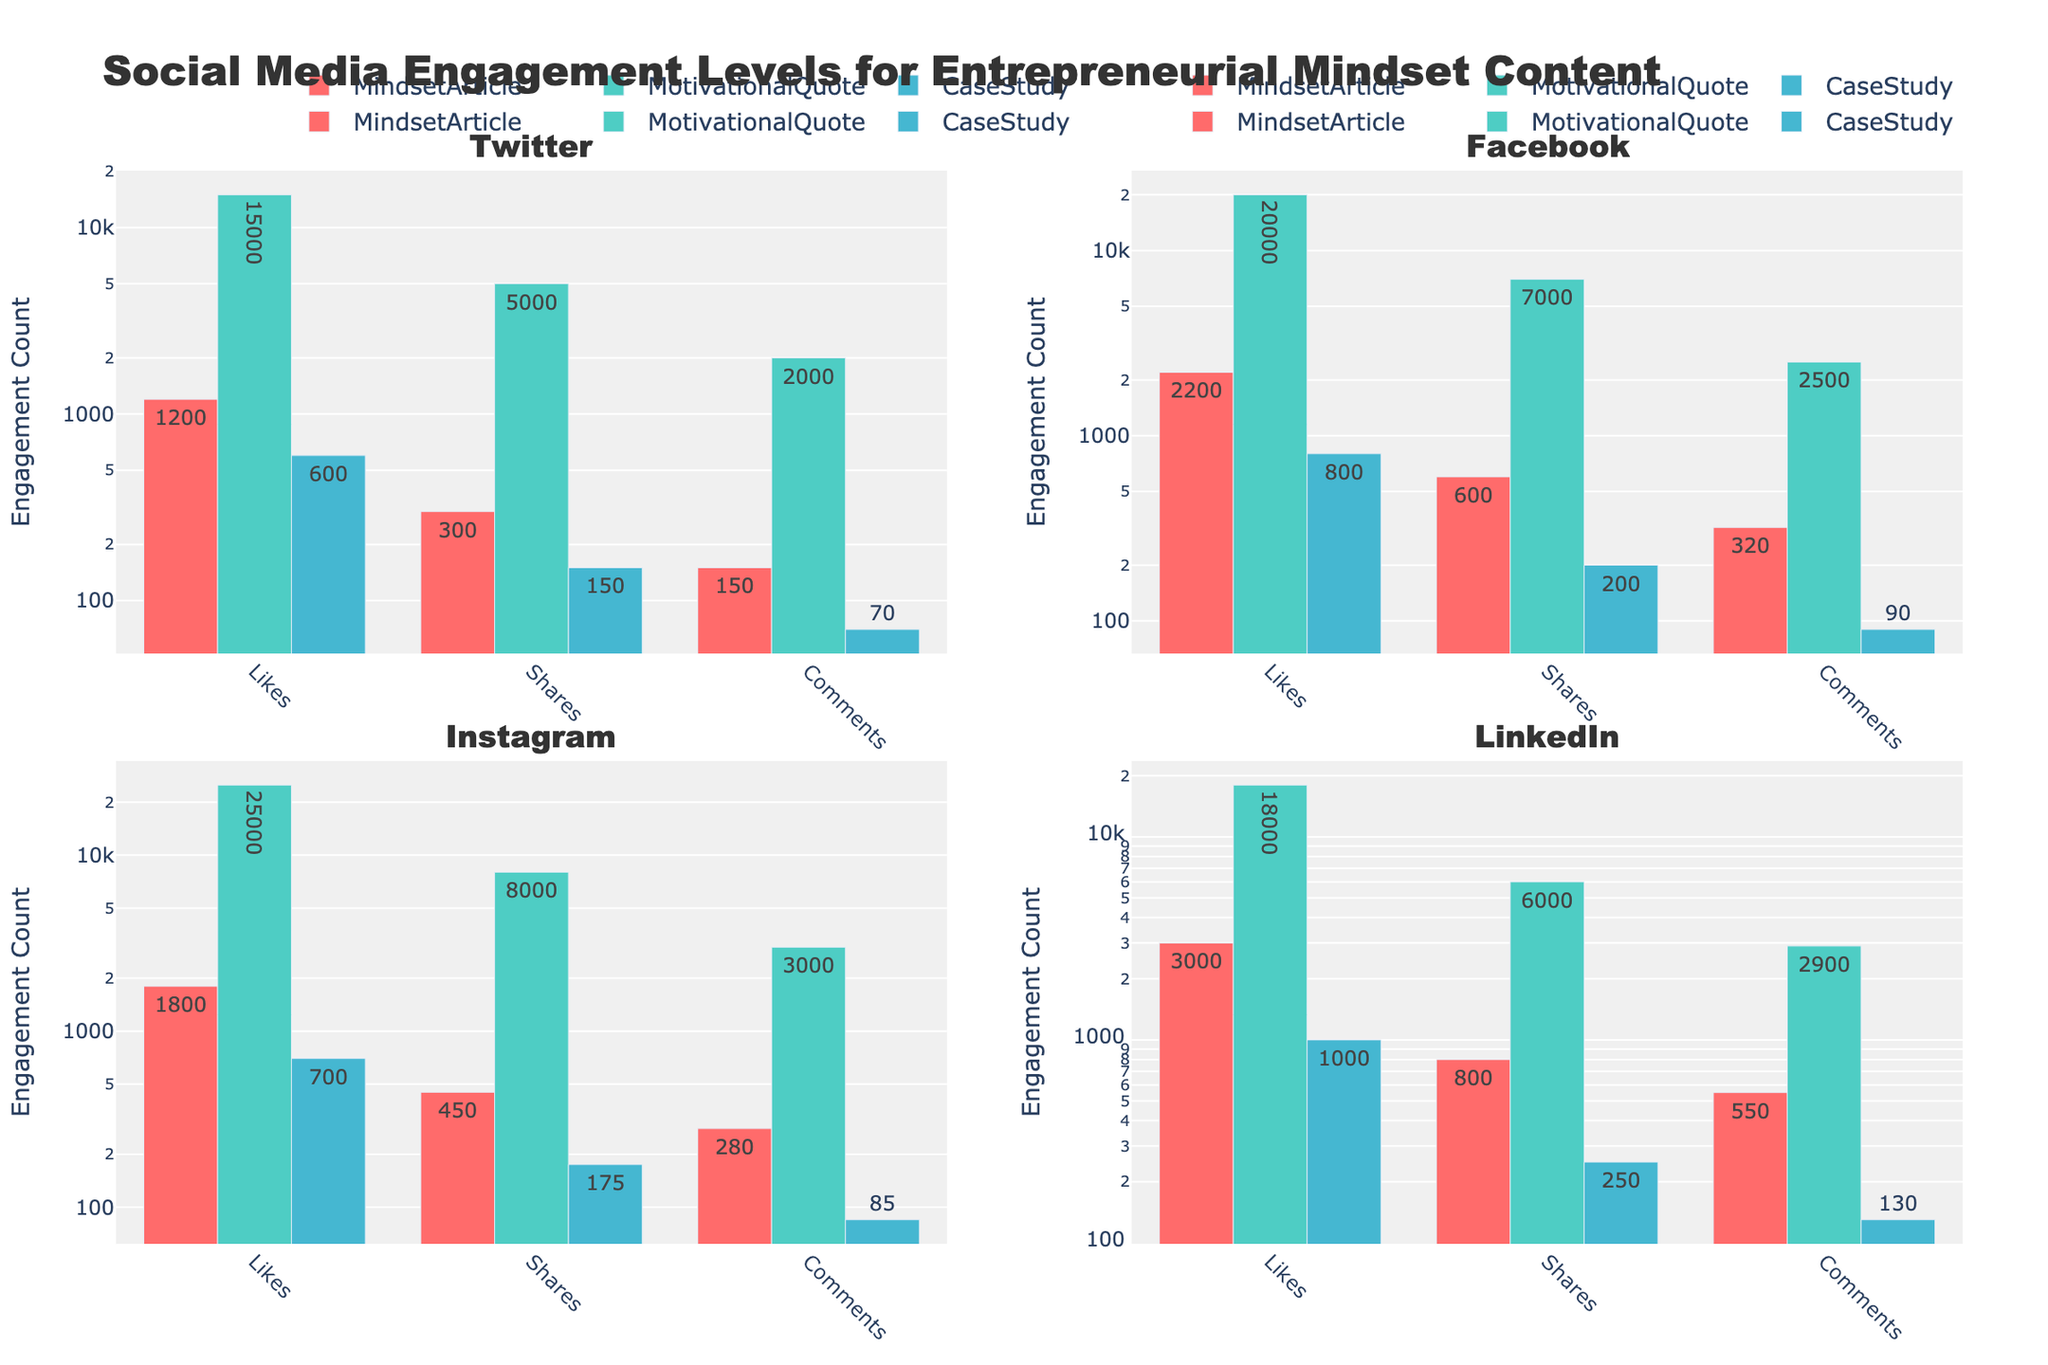What is the title of the plot? Look at the top of the figure where the main title is located. It indicates the overall theme or topic of the plot.
Answer: Social Media Engagement Levels for Entrepreneurial Mindset Content Which platform shows the highest number of likes for Mindset Articles? Compare the bars labeled "Likes" for Mindset Articles across all platforms. The highest bar represents the platform with the most likes.
Answer: LinkedIn How many likes are there for Motivational Quotes on Instagram? Find the bar that represents "Likes" for Motivational Quotes under the Instagram subplot. Read the value shown on the bar or the hovertext.
Answer: 25000 Which type of engagement has the lowest value for Case Studies on Twitter? Look at the subplot for Twitter, find the bars corresponding to Case Studies, and identify the shortest bar which represents the lowest value type of engagement.
Answer: Comments On Facebook, what is the difference in the number of shares between Motivational Quotes and Case Studies? Find the bars representing "Shares" for both Motivational Quotes and Case Studies on Facebook. Subtract the value for Case Studies from the value for Motivational Quotes.
Answer: 6800 Between Facebook and Twitter, which platform has higher comments for Mindset Articles? Compare the bars labeled "Comments" for Mindset Articles in both the Facebook and Twitter subplots. Identify the platform with the taller bar.
Answer: Facebook What is the average number of likes for Motivational Quotes across all platforms? Calculate the sum of likes for Motivational Quotes across all platforms (15000 + 20000 + 25000 + 18000) and divide by the number of platforms (4).
Answer: 19500 Compare the shares for Case Studies on LinkedIn and Instagram. Which one is greater and by how much? Look at the subplot for LinkedIn and Instagram, find the bars representing "Shares" for Case Studies on each platform, and compare their heights. Subtract the smaller value from the larger value to find the difference.
Answer: LinkedIn by 75 What is the general trend in the number of likes for Motivational Quotes compared to other content types across platforms? Observe the height of bars representing "Likes" for Motivational Quotes in all subplots and compare them with the bars for other content types like Mindset Articles and Case Studies.
Answer: Motivational Quotes generally receive higher likes across all platforms How do the engagement levels for Mindset Articles compare between Instagram and Facebook? Compare the heights of the bars representing "Likes," "Shares," and "Comments" for Mindset Articles between the subplots for Instagram and Facebook. Identify which platform has taller bars and for which types of engagement.
Answer: Facebook generally has higher engagement levels 